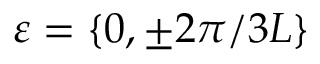<formula> <loc_0><loc_0><loc_500><loc_500>\varepsilon = \{ 0 , \pm 2 \pi / 3 L \}</formula> 